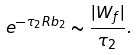Convert formula to latex. <formula><loc_0><loc_0><loc_500><loc_500>e ^ { - \tau _ { 2 } R b _ { 2 } } \sim \frac { | W _ { f } | } { \tau _ { 2 } } .</formula> 